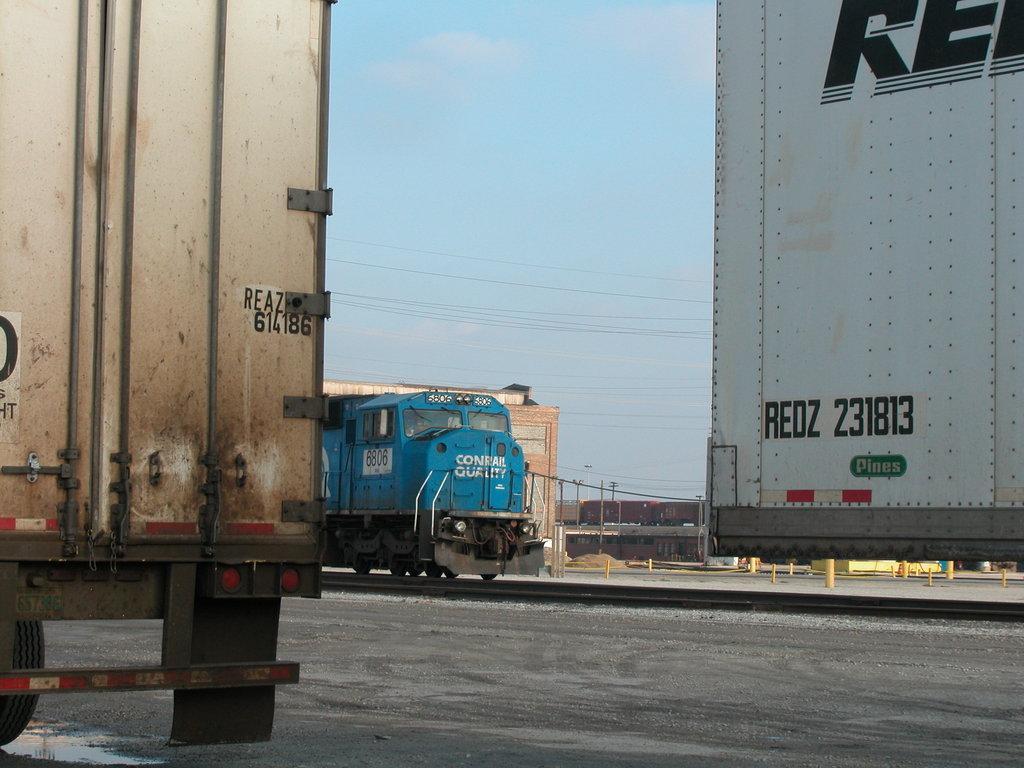How would you summarize this image in a sentence or two? On the right and left side of the image there are trucks, in the center of the image there is a train on the tracks, behind the train there is a building, metal rods, lamp posts, in the background of the image there is a train, at the top of the image there are cables. 